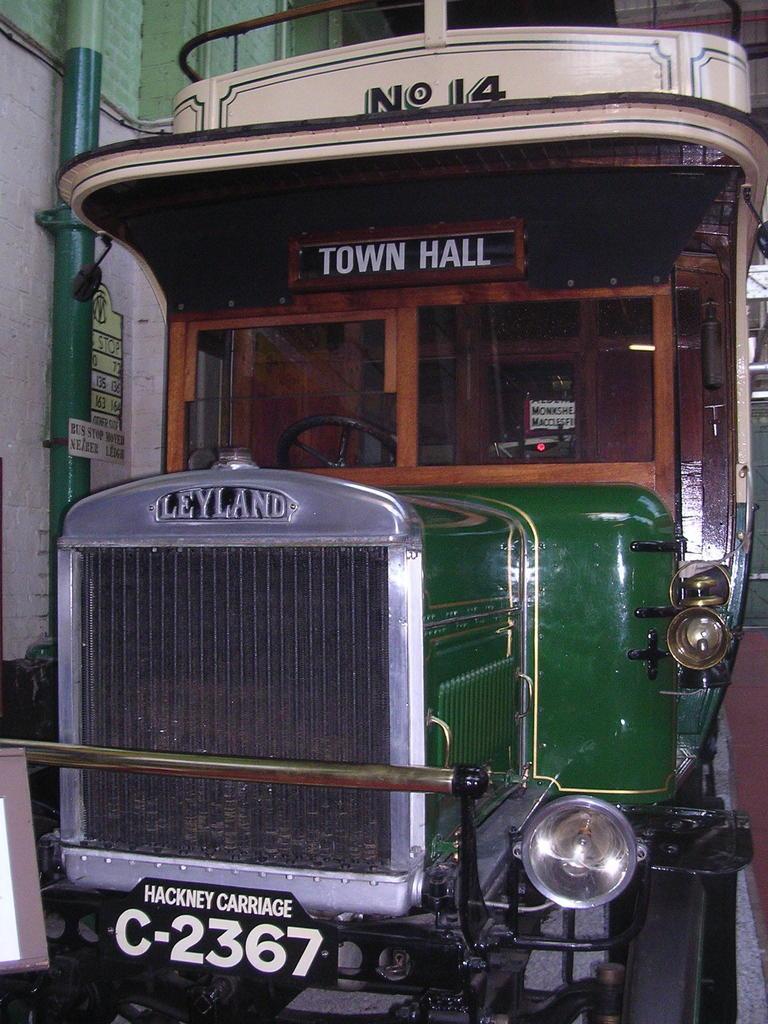Describe this image in one or two sentences. In this image I can see a vehicle. On the right side there is a platform. On the left side there is a pole attached to the wall. To this vehicle few name boards are attached. 